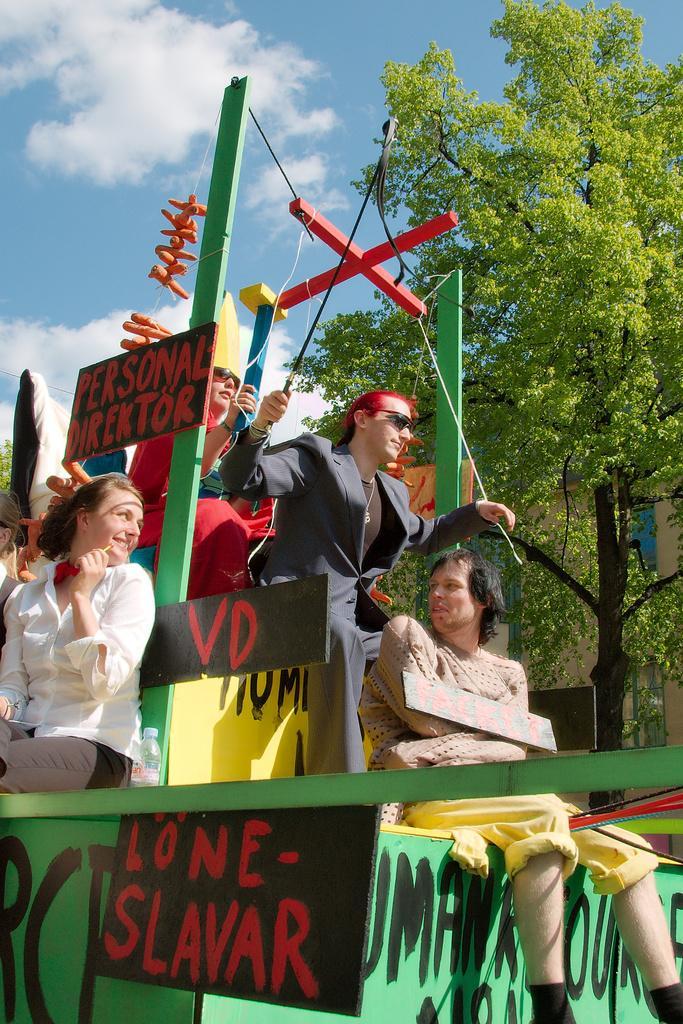Describe this image in one or two sentences. This is an outside view. Here I can see few people are sitting on a vehicle and there are some boards are attached to this vehicle. In the background, I can see a tree and a building. At the top I can see the sky and clouds. 